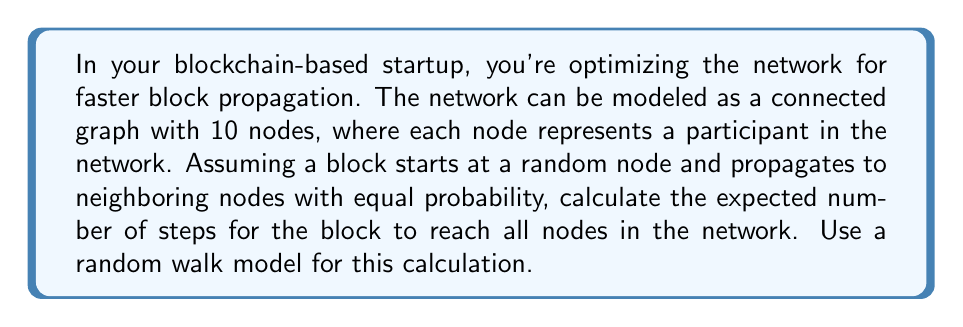Can you solve this math problem? Let's approach this step-by-step:

1) First, we need to understand what we're calculating. We're looking for the expected number of steps for a random walk to visit all nodes in a graph. This is known as the cover time of the graph.

2) For a connected graph with $n$ nodes, an upper bound for the cover time is given by the formula:

   $$C(G) \leq 4n^3/27$$

   Where $C(G)$ is the cover time and $n$ is the number of nodes.

3) In our case, $n = 10$. Let's substitute this into the formula:

   $$C(G) \leq 4(10^3)/27$$

4) Let's calculate this:

   $$C(G) \leq 4(1000)/27 = 4000/27 \approx 148.15$$

5) Therefore, the expected number of steps for the block to reach all nodes is at most 149 (rounding up).

6) It's important to note that this is an upper bound. The actual expected cover time could be less, depending on the specific structure of the graph. In practice, blockchain networks often use more efficient propagation methods, but this random walk model provides a baseline for comparison.
Answer: $\leq 149$ steps 